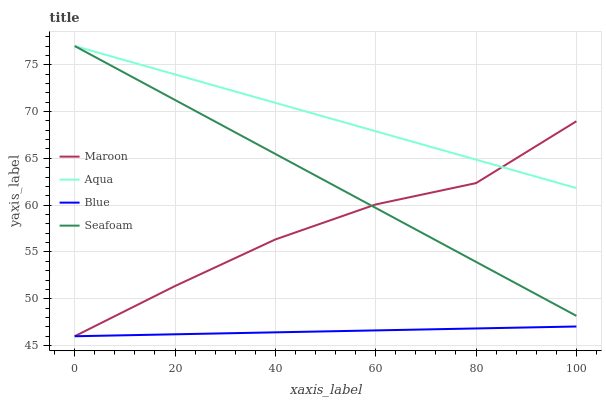Does Blue have the minimum area under the curve?
Answer yes or no. Yes. Does Aqua have the maximum area under the curve?
Answer yes or no. Yes. Does Seafoam have the minimum area under the curve?
Answer yes or no. No. Does Seafoam have the maximum area under the curve?
Answer yes or no. No. Is Blue the smoothest?
Answer yes or no. Yes. Is Maroon the roughest?
Answer yes or no. Yes. Is Aqua the smoothest?
Answer yes or no. No. Is Aqua the roughest?
Answer yes or no. No. Does Blue have the lowest value?
Answer yes or no. Yes. Does Seafoam have the lowest value?
Answer yes or no. No. Does Seafoam have the highest value?
Answer yes or no. Yes. Does Maroon have the highest value?
Answer yes or no. No. Is Blue less than Aqua?
Answer yes or no. Yes. Is Seafoam greater than Blue?
Answer yes or no. Yes. Does Maroon intersect Seafoam?
Answer yes or no. Yes. Is Maroon less than Seafoam?
Answer yes or no. No. Is Maroon greater than Seafoam?
Answer yes or no. No. Does Blue intersect Aqua?
Answer yes or no. No. 